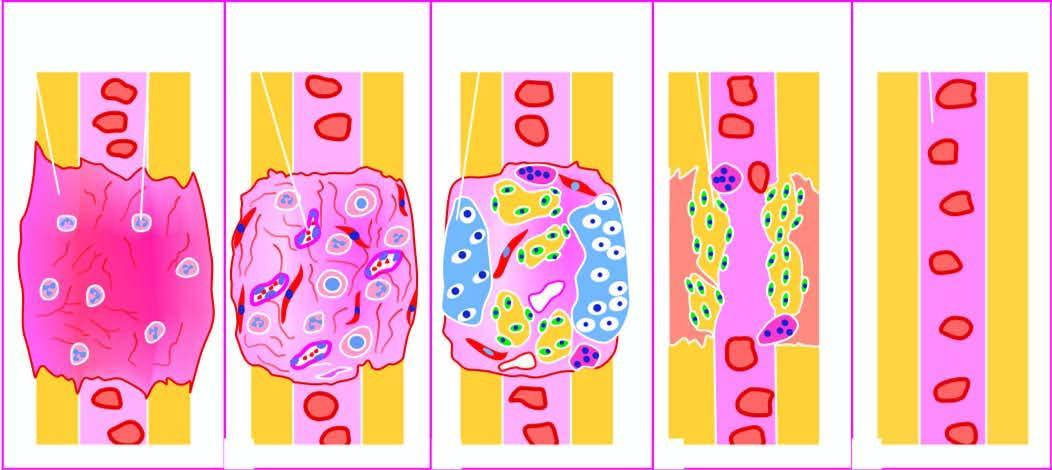what is intermediate callus converted into?
Answer the question using a single word or phrase. Lamellar bone and internal callus developing bone marrow cavity 